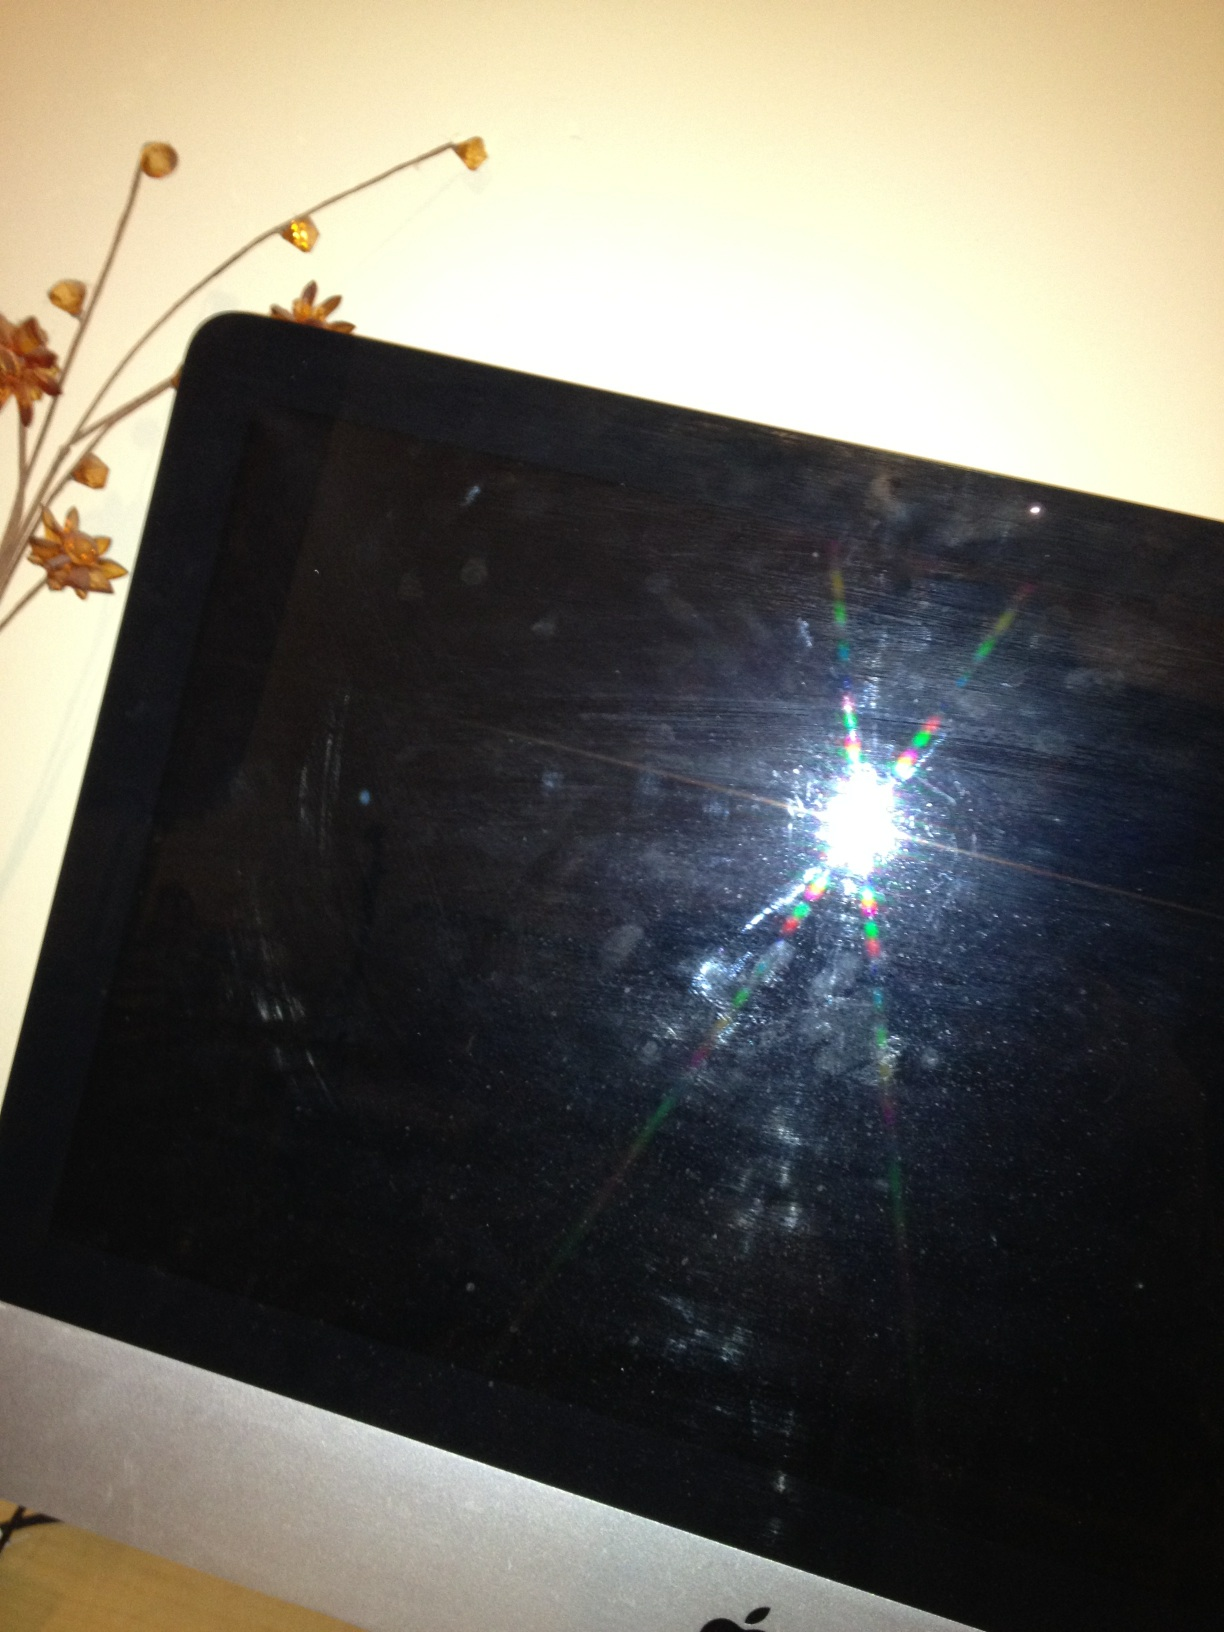Hello, could you please tell me what is written on this screen please? Thank you. There is nothing legible written on this screen. It appears to be mostly dark with some reflections of light and possibly some smudges. 